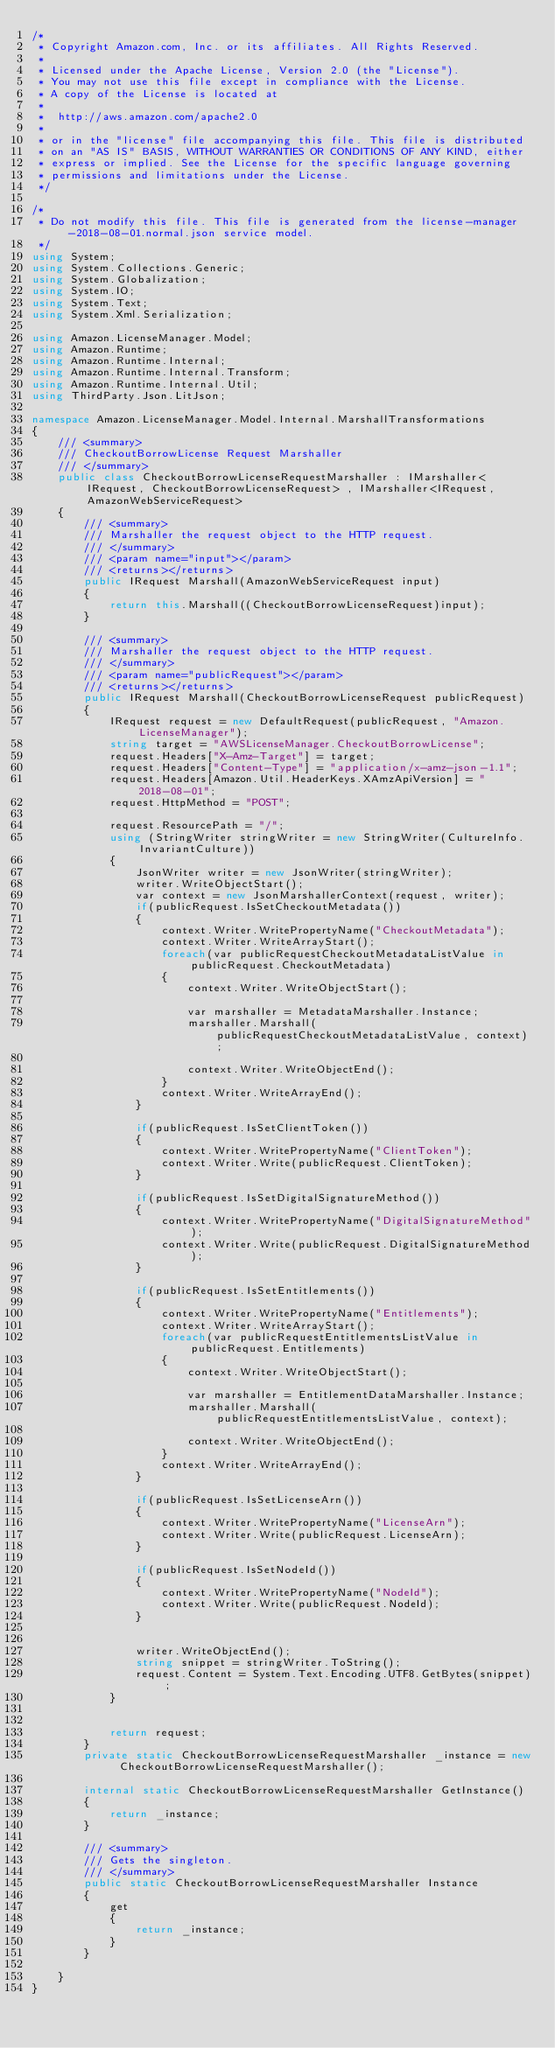Convert code to text. <code><loc_0><loc_0><loc_500><loc_500><_C#_>/*
 * Copyright Amazon.com, Inc. or its affiliates. All Rights Reserved.
 * 
 * Licensed under the Apache License, Version 2.0 (the "License").
 * You may not use this file except in compliance with the License.
 * A copy of the License is located at
 * 
 *  http://aws.amazon.com/apache2.0
 * 
 * or in the "license" file accompanying this file. This file is distributed
 * on an "AS IS" BASIS, WITHOUT WARRANTIES OR CONDITIONS OF ANY KIND, either
 * express or implied. See the License for the specific language governing
 * permissions and limitations under the License.
 */

/*
 * Do not modify this file. This file is generated from the license-manager-2018-08-01.normal.json service model.
 */
using System;
using System.Collections.Generic;
using System.Globalization;
using System.IO;
using System.Text;
using System.Xml.Serialization;

using Amazon.LicenseManager.Model;
using Amazon.Runtime;
using Amazon.Runtime.Internal;
using Amazon.Runtime.Internal.Transform;
using Amazon.Runtime.Internal.Util;
using ThirdParty.Json.LitJson;

namespace Amazon.LicenseManager.Model.Internal.MarshallTransformations
{
    /// <summary>
    /// CheckoutBorrowLicense Request Marshaller
    /// </summary>       
    public class CheckoutBorrowLicenseRequestMarshaller : IMarshaller<IRequest, CheckoutBorrowLicenseRequest> , IMarshaller<IRequest,AmazonWebServiceRequest>
    {
        /// <summary>
        /// Marshaller the request object to the HTTP request.
        /// </summary>  
        /// <param name="input"></param>
        /// <returns></returns>
        public IRequest Marshall(AmazonWebServiceRequest input)
        {
            return this.Marshall((CheckoutBorrowLicenseRequest)input);
        }

        /// <summary>
        /// Marshaller the request object to the HTTP request.
        /// </summary>  
        /// <param name="publicRequest"></param>
        /// <returns></returns>
        public IRequest Marshall(CheckoutBorrowLicenseRequest publicRequest)
        {
            IRequest request = new DefaultRequest(publicRequest, "Amazon.LicenseManager");
            string target = "AWSLicenseManager.CheckoutBorrowLicense";
            request.Headers["X-Amz-Target"] = target;
            request.Headers["Content-Type"] = "application/x-amz-json-1.1";
            request.Headers[Amazon.Util.HeaderKeys.XAmzApiVersion] = "2018-08-01";            
            request.HttpMethod = "POST";

            request.ResourcePath = "/";
            using (StringWriter stringWriter = new StringWriter(CultureInfo.InvariantCulture))
            {
                JsonWriter writer = new JsonWriter(stringWriter);
                writer.WriteObjectStart();
                var context = new JsonMarshallerContext(request, writer);
                if(publicRequest.IsSetCheckoutMetadata())
                {
                    context.Writer.WritePropertyName("CheckoutMetadata");
                    context.Writer.WriteArrayStart();
                    foreach(var publicRequestCheckoutMetadataListValue in publicRequest.CheckoutMetadata)
                    {
                        context.Writer.WriteObjectStart();

                        var marshaller = MetadataMarshaller.Instance;
                        marshaller.Marshall(publicRequestCheckoutMetadataListValue, context);

                        context.Writer.WriteObjectEnd();
                    }
                    context.Writer.WriteArrayEnd();
                }

                if(publicRequest.IsSetClientToken())
                {
                    context.Writer.WritePropertyName("ClientToken");
                    context.Writer.Write(publicRequest.ClientToken);
                }

                if(publicRequest.IsSetDigitalSignatureMethod())
                {
                    context.Writer.WritePropertyName("DigitalSignatureMethod");
                    context.Writer.Write(publicRequest.DigitalSignatureMethod);
                }

                if(publicRequest.IsSetEntitlements())
                {
                    context.Writer.WritePropertyName("Entitlements");
                    context.Writer.WriteArrayStart();
                    foreach(var publicRequestEntitlementsListValue in publicRequest.Entitlements)
                    {
                        context.Writer.WriteObjectStart();

                        var marshaller = EntitlementDataMarshaller.Instance;
                        marshaller.Marshall(publicRequestEntitlementsListValue, context);

                        context.Writer.WriteObjectEnd();
                    }
                    context.Writer.WriteArrayEnd();
                }

                if(publicRequest.IsSetLicenseArn())
                {
                    context.Writer.WritePropertyName("LicenseArn");
                    context.Writer.Write(publicRequest.LicenseArn);
                }

                if(publicRequest.IsSetNodeId())
                {
                    context.Writer.WritePropertyName("NodeId");
                    context.Writer.Write(publicRequest.NodeId);
                }

        
                writer.WriteObjectEnd();
                string snippet = stringWriter.ToString();
                request.Content = System.Text.Encoding.UTF8.GetBytes(snippet);
            }


            return request;
        }
        private static CheckoutBorrowLicenseRequestMarshaller _instance = new CheckoutBorrowLicenseRequestMarshaller();        

        internal static CheckoutBorrowLicenseRequestMarshaller GetInstance()
        {
            return _instance;
        }

        /// <summary>
        /// Gets the singleton.
        /// </summary>  
        public static CheckoutBorrowLicenseRequestMarshaller Instance
        {
            get
            {
                return _instance;
            }
        }

    }
}</code> 